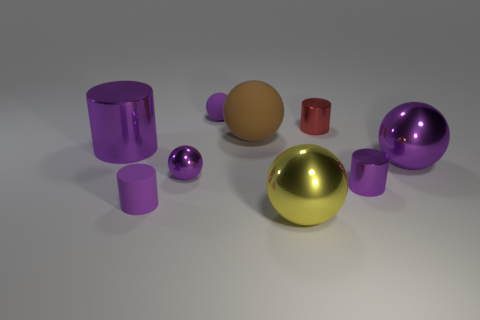Which object seems to be the focal point in this image, and why might that be? The large gold shiny sphere is positioned centrally and appears to be the focal point due to its size, prominent placement, and reflective surface that naturally draws the viewer's gaze amid the other objects. Considering its position as the focal point, how might lighting be influencing its appearance? The lighting enhances the sphere's reflective properties, creating vivid highlights and soft shadows that underscore its three-dimensional form. It also accentuates the texture contrast between the glossy finish of the sphere and the more subdued surfaces of the surrounding items. 